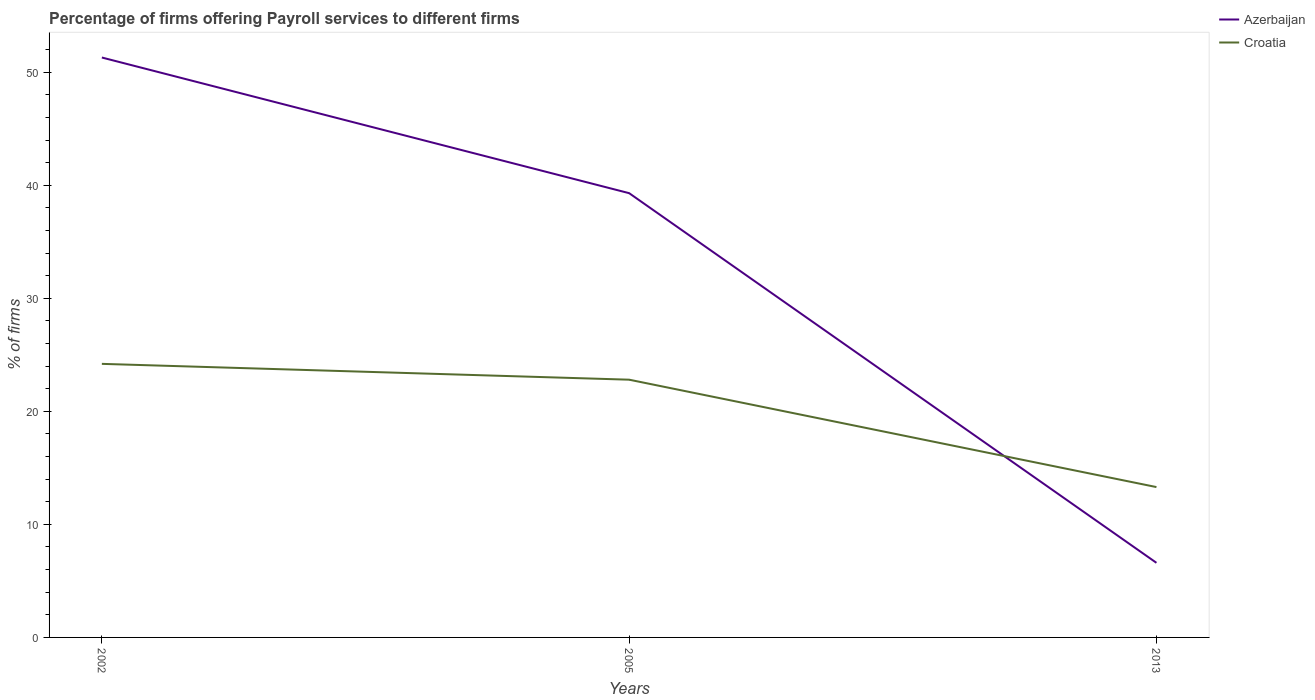Across all years, what is the maximum percentage of firms offering payroll services in Azerbaijan?
Ensure brevity in your answer.  6.6. What is the total percentage of firms offering payroll services in Azerbaijan in the graph?
Give a very brief answer. 32.7. What is the difference between the highest and the second highest percentage of firms offering payroll services in Azerbaijan?
Provide a short and direct response. 44.7. What is the difference between two consecutive major ticks on the Y-axis?
Keep it short and to the point. 10. Are the values on the major ticks of Y-axis written in scientific E-notation?
Ensure brevity in your answer.  No. Does the graph contain any zero values?
Make the answer very short. No. Where does the legend appear in the graph?
Make the answer very short. Top right. How many legend labels are there?
Give a very brief answer. 2. What is the title of the graph?
Your answer should be very brief. Percentage of firms offering Payroll services to different firms. Does "Slovak Republic" appear as one of the legend labels in the graph?
Your answer should be very brief. No. What is the label or title of the X-axis?
Give a very brief answer. Years. What is the label or title of the Y-axis?
Keep it short and to the point. % of firms. What is the % of firms in Azerbaijan in 2002?
Your answer should be compact. 51.3. What is the % of firms of Croatia in 2002?
Provide a short and direct response. 24.2. What is the % of firms in Azerbaijan in 2005?
Your answer should be very brief. 39.3. What is the % of firms of Croatia in 2005?
Make the answer very short. 22.8. What is the % of firms in Azerbaijan in 2013?
Your answer should be very brief. 6.6. What is the % of firms of Croatia in 2013?
Give a very brief answer. 13.3. Across all years, what is the maximum % of firms in Azerbaijan?
Your response must be concise. 51.3. Across all years, what is the maximum % of firms in Croatia?
Ensure brevity in your answer.  24.2. What is the total % of firms of Azerbaijan in the graph?
Your answer should be very brief. 97.2. What is the total % of firms of Croatia in the graph?
Offer a very short reply. 60.3. What is the difference between the % of firms of Azerbaijan in 2002 and that in 2005?
Keep it short and to the point. 12. What is the difference between the % of firms of Azerbaijan in 2002 and that in 2013?
Keep it short and to the point. 44.7. What is the difference between the % of firms in Croatia in 2002 and that in 2013?
Your answer should be compact. 10.9. What is the difference between the % of firms in Azerbaijan in 2005 and that in 2013?
Your answer should be compact. 32.7. What is the difference between the % of firms in Azerbaijan in 2002 and the % of firms in Croatia in 2005?
Your response must be concise. 28.5. What is the difference between the % of firms of Azerbaijan in 2005 and the % of firms of Croatia in 2013?
Make the answer very short. 26. What is the average % of firms in Azerbaijan per year?
Your response must be concise. 32.4. What is the average % of firms of Croatia per year?
Ensure brevity in your answer.  20.1. In the year 2002, what is the difference between the % of firms of Azerbaijan and % of firms of Croatia?
Ensure brevity in your answer.  27.1. What is the ratio of the % of firms of Azerbaijan in 2002 to that in 2005?
Keep it short and to the point. 1.31. What is the ratio of the % of firms of Croatia in 2002 to that in 2005?
Your answer should be compact. 1.06. What is the ratio of the % of firms in Azerbaijan in 2002 to that in 2013?
Keep it short and to the point. 7.77. What is the ratio of the % of firms in Croatia in 2002 to that in 2013?
Keep it short and to the point. 1.82. What is the ratio of the % of firms in Azerbaijan in 2005 to that in 2013?
Provide a succinct answer. 5.95. What is the ratio of the % of firms of Croatia in 2005 to that in 2013?
Your response must be concise. 1.71. What is the difference between the highest and the second highest % of firms of Azerbaijan?
Your response must be concise. 12. What is the difference between the highest and the second highest % of firms in Croatia?
Make the answer very short. 1.4. What is the difference between the highest and the lowest % of firms of Azerbaijan?
Your response must be concise. 44.7. 